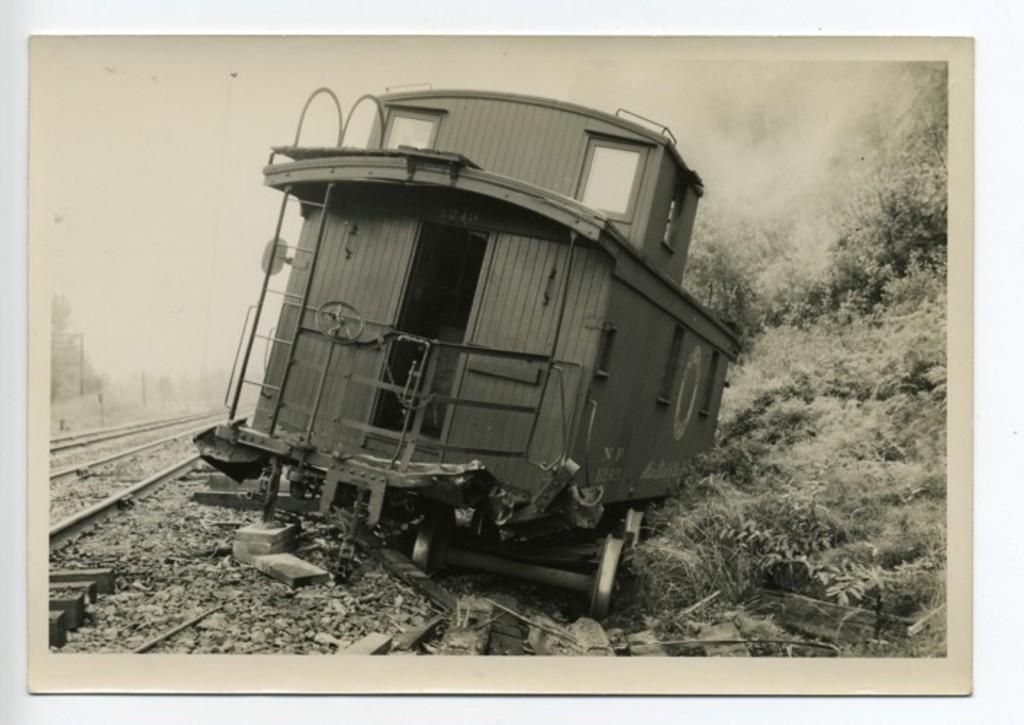What type of transportation infrastructure is present in the image? There are railway tracks in the image. What type of vegetation can be seen near the railway tracks? There is grass visible in the image. What is traveling along the railway tracks in the image? There is a train in the image. What is the color scheme of the image? The image is black and white in color. Who is the servant accompanying the stranger on their trip in the image? There is no servant or stranger present in the image; it features railway tracks, grass, and a train. 